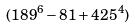<formula> <loc_0><loc_0><loc_500><loc_500>( 1 8 9 ^ { 6 } - 8 1 + 4 2 5 ^ { 4 } )</formula> 